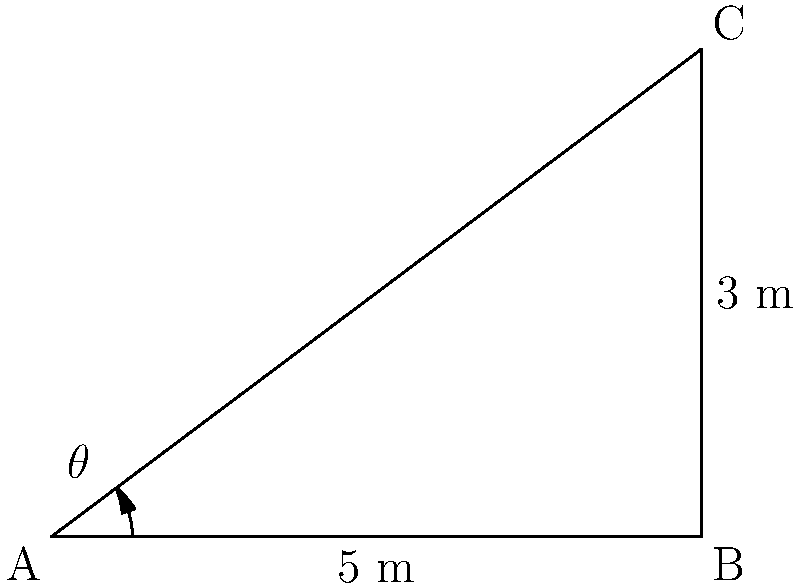In an artistic loft space, two walls intersect to form a unique corner. One wall is 5 meters long, and the other is 3 meters long. If you were to measure the angle between these walls, what would it be? Round your answer to the nearest degree. To find the angle between the two walls, we can use the inverse tangent (arctangent) function. Here's how:

1) First, we need to identify that this situation forms a right triangle. The two walls are the base and height of the triangle, and the angle we're looking for is at the corner where they meet.

2) In a right triangle, the tangent of an angle is the ratio of the opposite side to the adjacent side.

3) In this case, we have:
   Adjacent side (base) = 5 meters
   Opposite side (height) = 3 meters

4) The formula for the angle $\theta$ is:

   $$\theta = \arctan(\frac{\text{opposite}}{\text{adjacent}})$$

5) Plugging in our values:

   $$\theta = \arctan(\frac{3}{5})$$

6) Using a calculator or computer:

   $$\theta \approx 30.9638^\circ$$

7) Rounding to the nearest degree:

   $$\theta \approx 31^\circ$$

Therefore, the angle between the two walls is approximately 31 degrees.
Answer: $31^\circ$ 